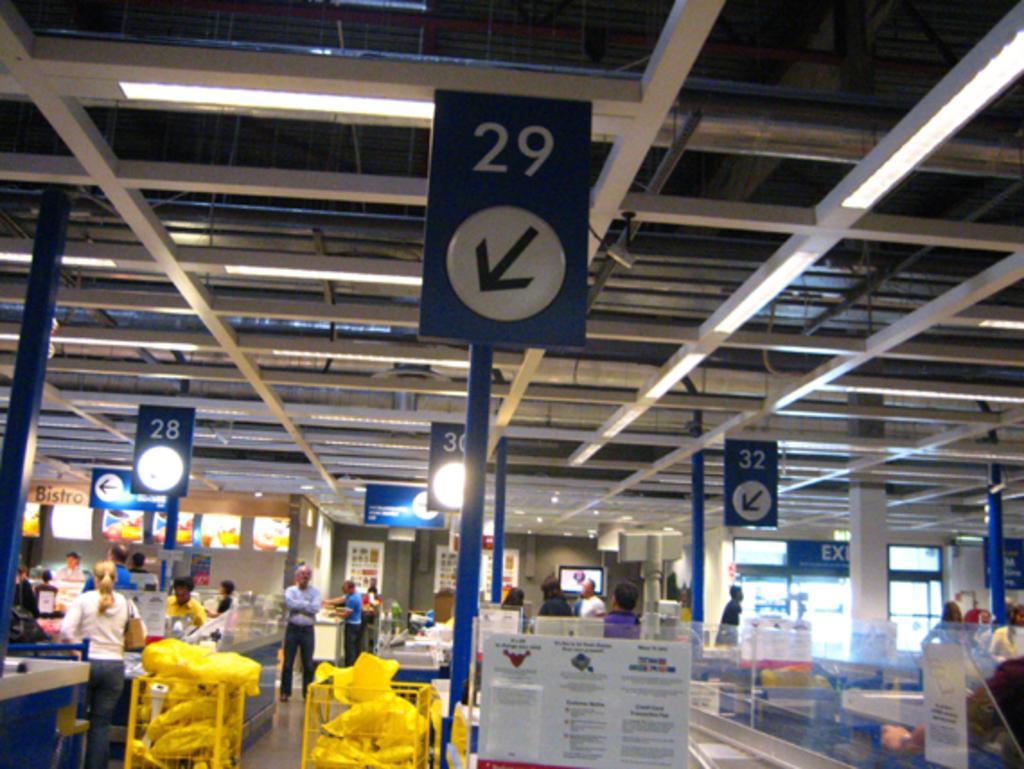Please provide a concise description of this image. The image is captured inside the billing counter of a store, there are some items kept in the trolleys and around the counters there are few people and there are some boards with arrow marks and numbers, in the background there is an exit door on the right side. 